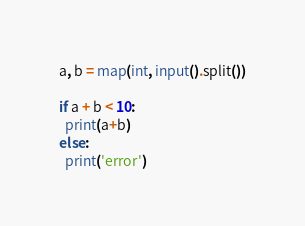Convert code to text. <code><loc_0><loc_0><loc_500><loc_500><_Python_>a, b = map(int, input().split())

if a + b < 10:
  print(a+b)
else:
  print('error')</code> 